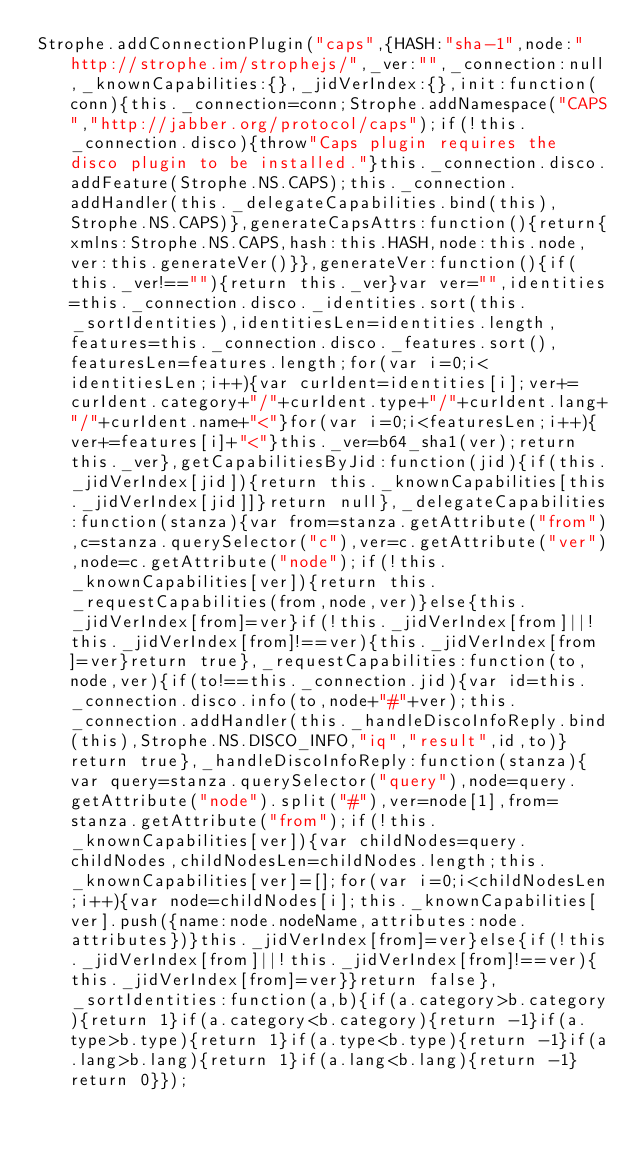Convert code to text. <code><loc_0><loc_0><loc_500><loc_500><_JavaScript_>Strophe.addConnectionPlugin("caps",{HASH:"sha-1",node:"http://strophe.im/strophejs/",_ver:"",_connection:null,_knownCapabilities:{},_jidVerIndex:{},init:function(conn){this._connection=conn;Strophe.addNamespace("CAPS","http://jabber.org/protocol/caps");if(!this._connection.disco){throw"Caps plugin requires the disco plugin to be installed."}this._connection.disco.addFeature(Strophe.NS.CAPS);this._connection.addHandler(this._delegateCapabilities.bind(this),Strophe.NS.CAPS)},generateCapsAttrs:function(){return{xmlns:Strophe.NS.CAPS,hash:this.HASH,node:this.node,ver:this.generateVer()}},generateVer:function(){if(this._ver!==""){return this._ver}var ver="",identities=this._connection.disco._identities.sort(this._sortIdentities),identitiesLen=identities.length,features=this._connection.disco._features.sort(),featuresLen=features.length;for(var i=0;i<identitiesLen;i++){var curIdent=identities[i];ver+=curIdent.category+"/"+curIdent.type+"/"+curIdent.lang+"/"+curIdent.name+"<"}for(var i=0;i<featuresLen;i++){ver+=features[i]+"<"}this._ver=b64_sha1(ver);return this._ver},getCapabilitiesByJid:function(jid){if(this._jidVerIndex[jid]){return this._knownCapabilities[this._jidVerIndex[jid]]}return null},_delegateCapabilities:function(stanza){var from=stanza.getAttribute("from"),c=stanza.querySelector("c"),ver=c.getAttribute("ver"),node=c.getAttribute("node");if(!this._knownCapabilities[ver]){return this._requestCapabilities(from,node,ver)}else{this._jidVerIndex[from]=ver}if(!this._jidVerIndex[from]||!this._jidVerIndex[from]!==ver){this._jidVerIndex[from]=ver}return true},_requestCapabilities:function(to,node,ver){if(to!==this._connection.jid){var id=this._connection.disco.info(to,node+"#"+ver);this._connection.addHandler(this._handleDiscoInfoReply.bind(this),Strophe.NS.DISCO_INFO,"iq","result",id,to)}return true},_handleDiscoInfoReply:function(stanza){var query=stanza.querySelector("query"),node=query.getAttribute("node").split("#"),ver=node[1],from=stanza.getAttribute("from");if(!this._knownCapabilities[ver]){var childNodes=query.childNodes,childNodesLen=childNodes.length;this._knownCapabilities[ver]=[];for(var i=0;i<childNodesLen;i++){var node=childNodes[i];this._knownCapabilities[ver].push({name:node.nodeName,attributes:node.attributes})}this._jidVerIndex[from]=ver}else{if(!this._jidVerIndex[from]||!this._jidVerIndex[from]!==ver){this._jidVerIndex[from]=ver}}return false},_sortIdentities:function(a,b){if(a.category>b.category){return 1}if(a.category<b.category){return -1}if(a.type>b.type){return 1}if(a.type<b.type){return -1}if(a.lang>b.lang){return 1}if(a.lang<b.lang){return -1}return 0}});</code> 